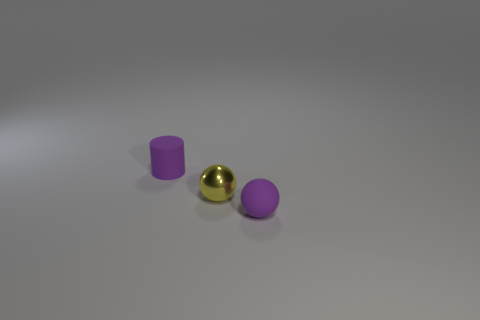Are there any other rubber spheres of the same color as the rubber sphere?
Make the answer very short. No. What number of cubes are either tiny shiny objects or small purple objects?
Provide a short and direct response. 0. Are there any other small shiny things that have the same shape as the yellow shiny thing?
Provide a succinct answer. No. How many other things are the same color as the small cylinder?
Your answer should be very brief. 1. Is the number of tiny metal objects to the right of the yellow sphere less than the number of large cyan metal spheres?
Your answer should be compact. No. How many small yellow spheres are there?
Provide a succinct answer. 1. What number of purple objects are the same material as the small purple cylinder?
Your response must be concise. 1. How many things are purple matte objects that are on the left side of the yellow shiny ball or tiny metallic things?
Offer a very short reply. 2. Are there fewer spheres on the left side of the small yellow sphere than tiny rubber balls that are behind the cylinder?
Provide a short and direct response. No. Are there any rubber things on the left side of the matte cylinder?
Offer a very short reply. No. 